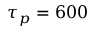Convert formula to latex. <formula><loc_0><loc_0><loc_500><loc_500>\tau _ { p } = 6 0 0</formula> 